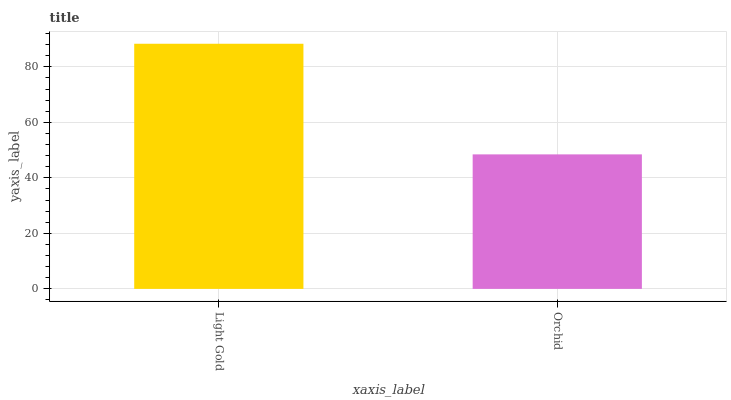Is Orchid the minimum?
Answer yes or no. Yes. Is Light Gold the maximum?
Answer yes or no. Yes. Is Orchid the maximum?
Answer yes or no. No. Is Light Gold greater than Orchid?
Answer yes or no. Yes. Is Orchid less than Light Gold?
Answer yes or no. Yes. Is Orchid greater than Light Gold?
Answer yes or no. No. Is Light Gold less than Orchid?
Answer yes or no. No. Is Light Gold the high median?
Answer yes or no. Yes. Is Orchid the low median?
Answer yes or no. Yes. Is Orchid the high median?
Answer yes or no. No. Is Light Gold the low median?
Answer yes or no. No. 